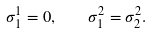<formula> <loc_0><loc_0><loc_500><loc_500>\sigma ^ { 1 } _ { 1 } = 0 , \quad \sigma ^ { 2 } _ { 1 } = \sigma ^ { 2 } _ { 2 } .</formula> 